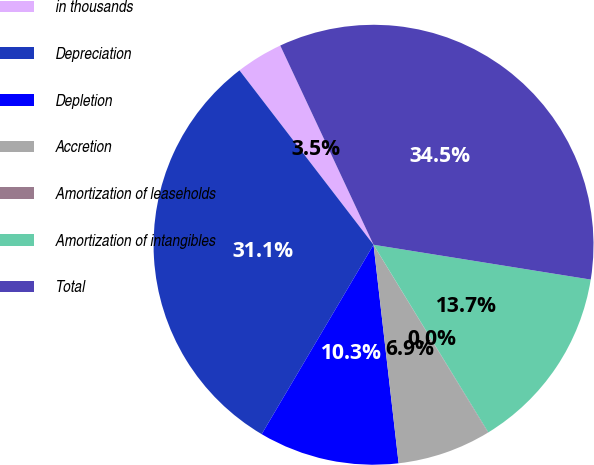Convert chart to OTSL. <chart><loc_0><loc_0><loc_500><loc_500><pie_chart><fcel>in thousands<fcel>Depreciation<fcel>Depletion<fcel>Accretion<fcel>Amortization of leaseholds<fcel>Amortization of intangibles<fcel>Total<nl><fcel>3.46%<fcel>31.08%<fcel>10.31%<fcel>6.88%<fcel>0.04%<fcel>13.73%<fcel>34.5%<nl></chart> 